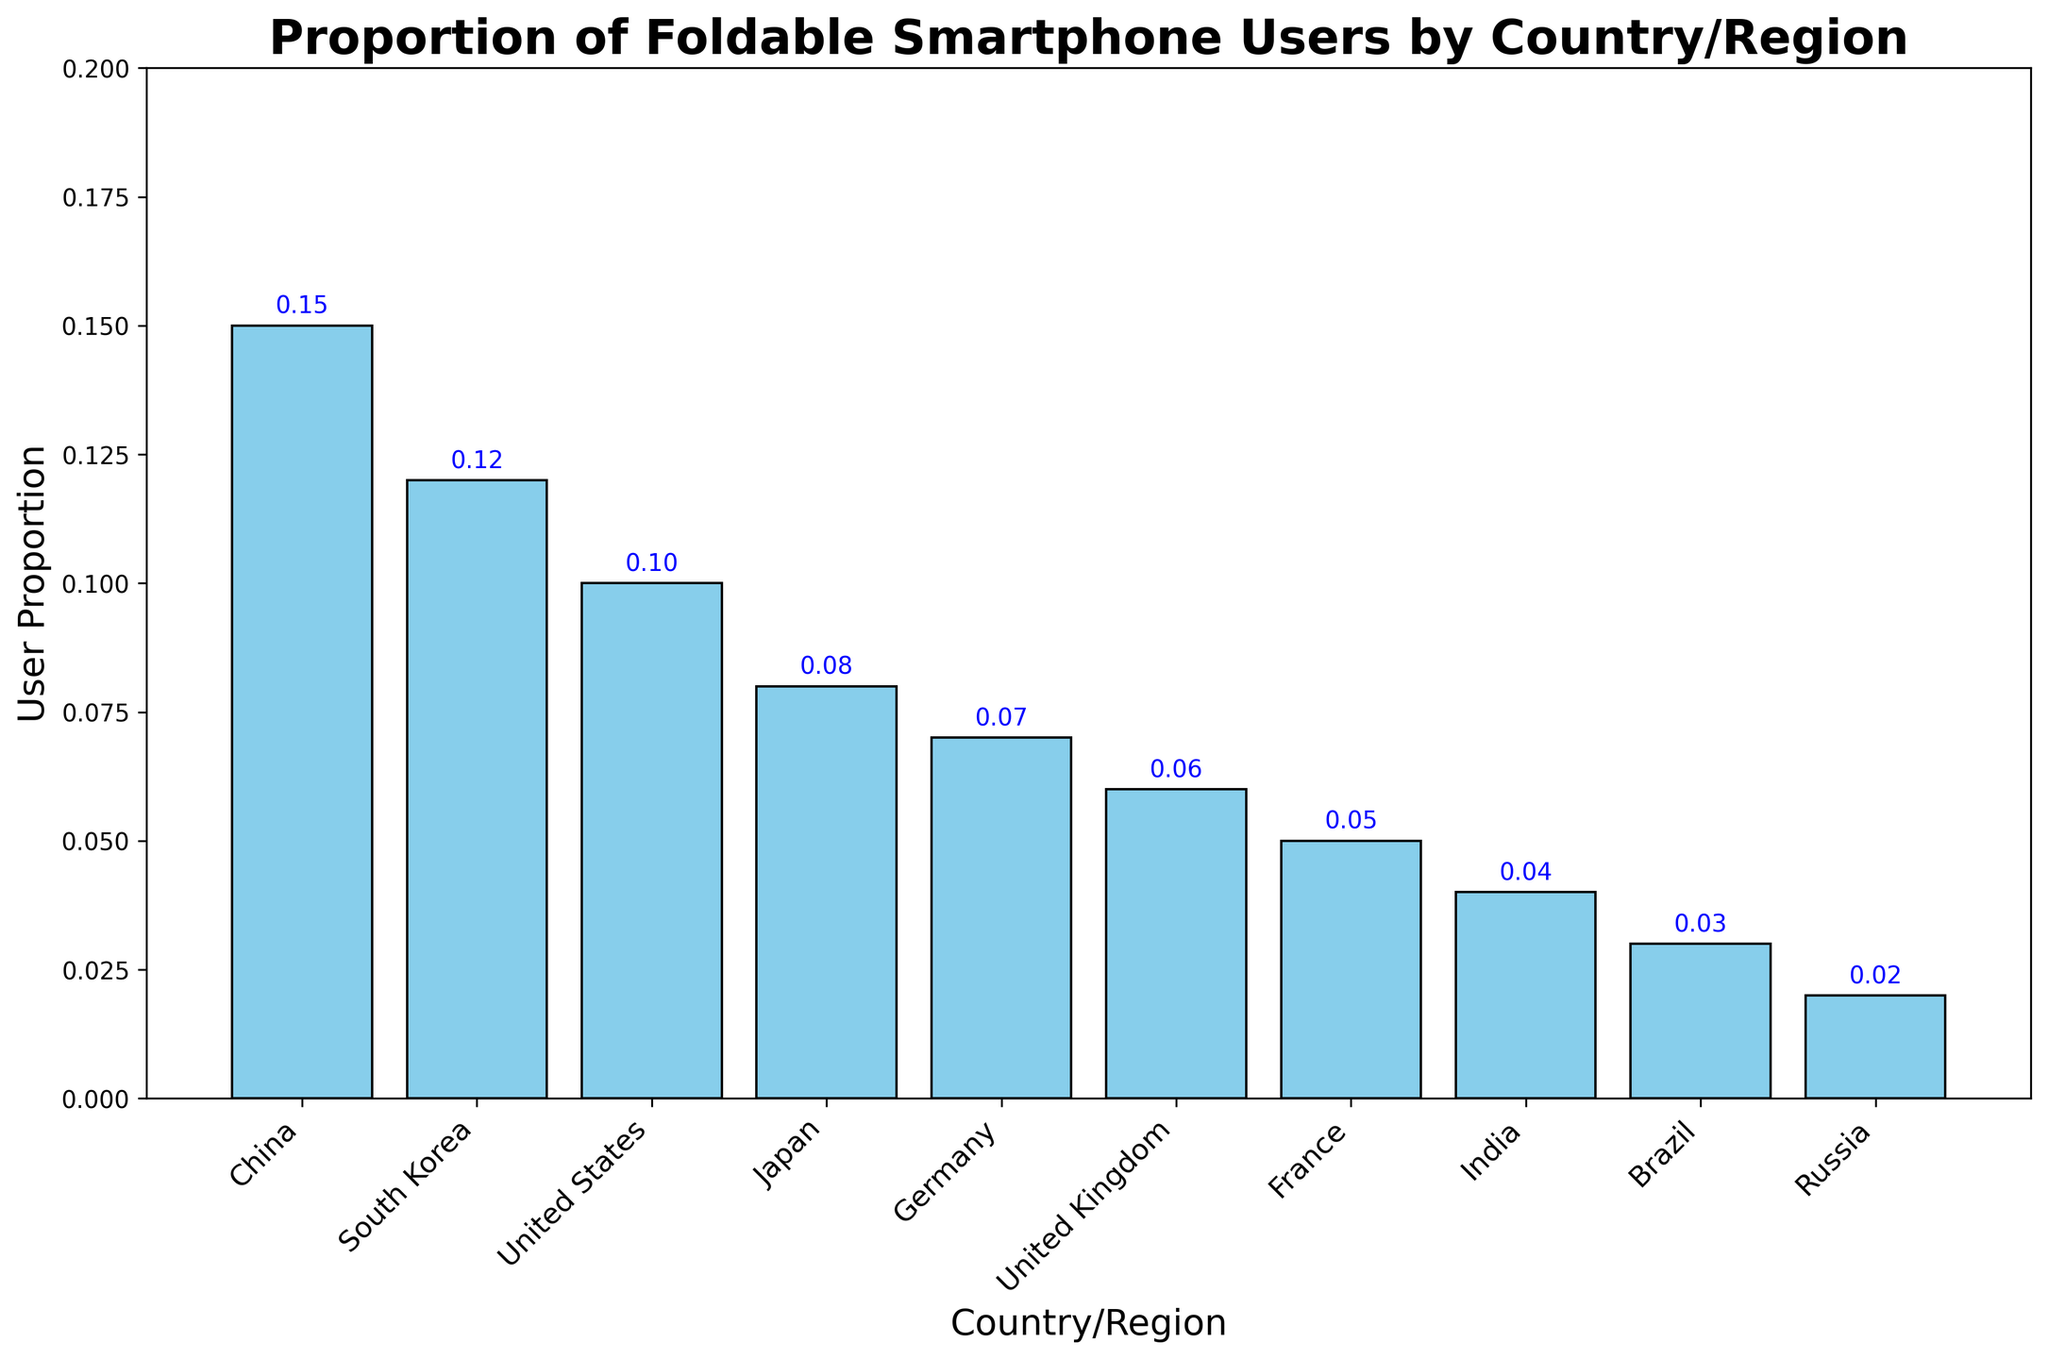Which country/region has the highest proportion of foldable smartphone users? The bar representing China is the tallest among all the bars, indicating the highest proportion.
Answer: China Which country/region has the lowest proportion of foldable smartphone users? The bar representing Russia is the shortest among all the bars, indicating the lowest proportion.
Answer: Russia How much higher is the proportion of foldable smartphone users in China compared to that in the United States? The proportion in China is 0.15 and in the United States is 0.10. The difference is 0.15 - 0.10 = 0.05.
Answer: 0.05 What is the combined proportion of foldable smartphone users in China, South Korea, and the United States? Sum the proportions: 0.15 (China) + 0.12 (South Korea) + 0.10 (United States) = 0.37.
Answer: 0.37 Which two countries/regions have the closest proportions of foldable smartphone users? By comparing the heights of the bars, Germany (0.07) and the United Kingdom (0.06) have nearly similar proportions with a difference of only 0.01.
Answer: Germany and United Kingdom Is the proportion of foldable smartphone users in Japan greater than in Germany? The proportion in Japan is 0.08 and in Germany is 0.07. Since 0.08 > 0.07, Japan has a greater proportion.
Answer: Yes Calculate the average proportion of foldable smartphone users across all the listed countries/regions. Sum all proportions: 0.15 + 0.12 + 0.10 + 0.08 + 0.07 + 0.06 + 0.05 + 0.04 + 0.03 + 0.02 = 0.72. The number of countries/regions is 10. The average is 0.72 / 10 = 0.072.
Answer: 0.072 What is the ratio of the proportion of foldable smartphone users in South Korea to that in India? The proportion in South Korea is 0.12 and in India is 0.04. The ratio is 0.12 / 0.04 = 3.
Answer: 3 Are there more countries/regions with a proportion of foldable smartphone users above or below the average proportion? The average proportion is 0.072. Countries/regions above the average: China (0.15), South Korea (0.12), United States (0.10), Japan (0.08), Germany (0.07). Total is 5. Countries/regions below the average: United Kingdom (0.06), France (0.05), India (0.04), Brazil (0.03), Russia (0.02). Total is 5. The counts are equal.
Answer: Equal 